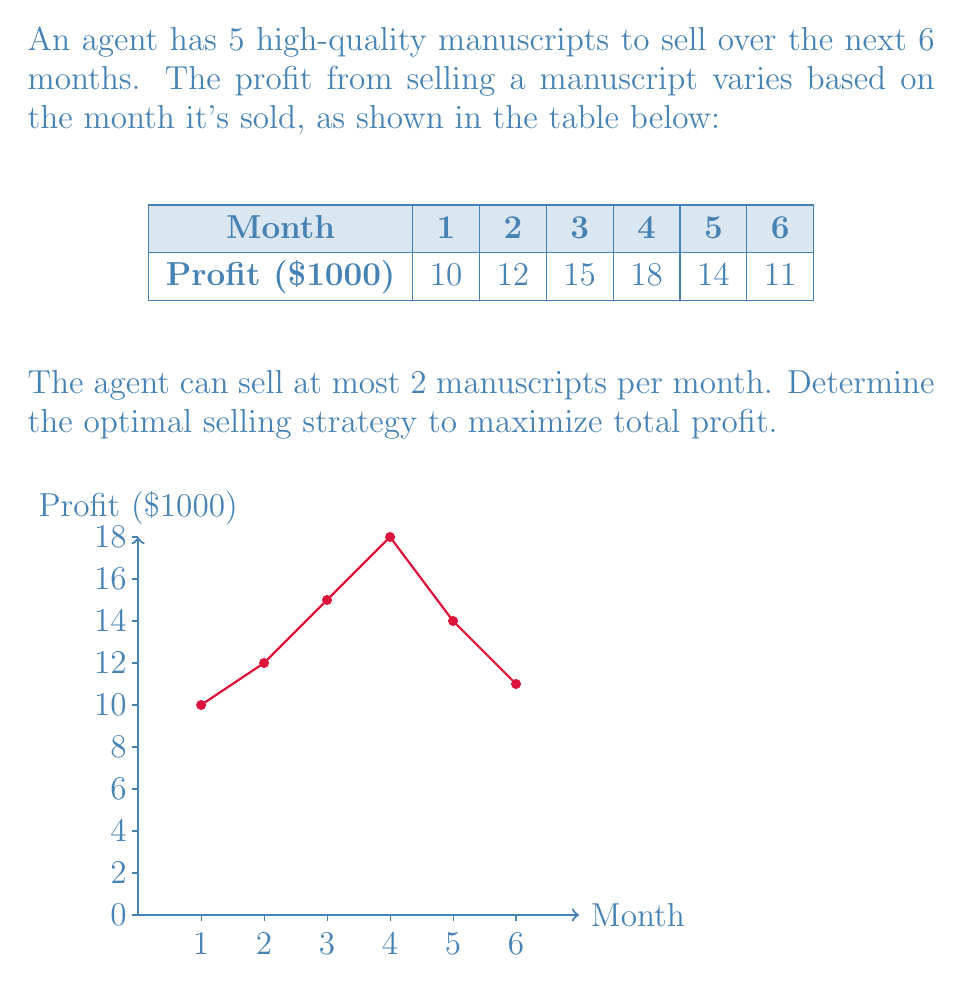Can you solve this math problem? Let's approach this step-by-step using dynamic programming:

1) Define variables:
   Let $x_i$ be the number of manuscripts sold in month $i$.

2) Objective function:
   Maximize $Z = 10x_1 + 12x_2 + 15x_3 + 18x_4 + 14x_5 + 11x_6$

3) Constraints:
   $\sum_{i=1}^6 x_i = 5$ (total manuscripts)
   $0 \leq x_i \leq 2$ for all $i$ (max 2 per month)
   $x_i$ are integers

4) Create a table for dynamic programming:
   Let $f(i,j)$ be the maximum profit from selling $j$ manuscripts in the first $i$ months.

5) Fill the table:
   For $i = 1$ to $6$ and $j = 0$ to $5$:
   $f(i,j) = \max_{k=0}^{\min(2,j)} \{f(i-1,j-k) + kp_i\}$
   where $p_i$ is the profit for month $i$.

6) The table (partial):

   |   | 0 | 1  | 2   | 3   | 4   | 5   |
   |---|---|----|----|-----|-----|-----|
   | 1 | 0 | 10 | 20 | 20  | 20  | 20  |
   | 2 | 0 | 12 | 24 | 34  | 44  | 44  |
   | 3 | 0 | 15 | 30 | 45  | 57  | 69  |
   | 4 | 0 | 18 | 36 | 54  | 72  | 87  |
   | 5 | 0 | 18 | 36 | 54  | 72  | 90  |
   | 6 | 0 | 18 | 36 | 54  | 72  | 90  |

7) Trace back to find the optimal solution:
   The maximum profit is 90 (bottom-right cell).
   Working backwards:
   Month 6: 0 manuscripts (90 - 90 = 0)
   Month 5: 0 manuscripts (90 - 90 = 0)
   Month 4: 2 manuscripts (90 - 54 = 36)
   Month 3: 2 manuscripts (54 - 24 = 30)
   Month 2: 1 manuscript  (24 - 12 = 12)
   Month 1: 0 manuscripts

Therefore, the optimal strategy is to sell 1 manuscript in month 2, and 2 manuscripts each in months 3 and 4.
Answer: Sell 1 in month 2, 2 in month 3, 2 in month 4; Max profit: $90,000 